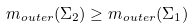<formula> <loc_0><loc_0><loc_500><loc_500>m _ { o u t e r } ( \Sigma _ { 2 } ) \geq m _ { o u t e r } ( \Sigma _ { 1 } )</formula> 